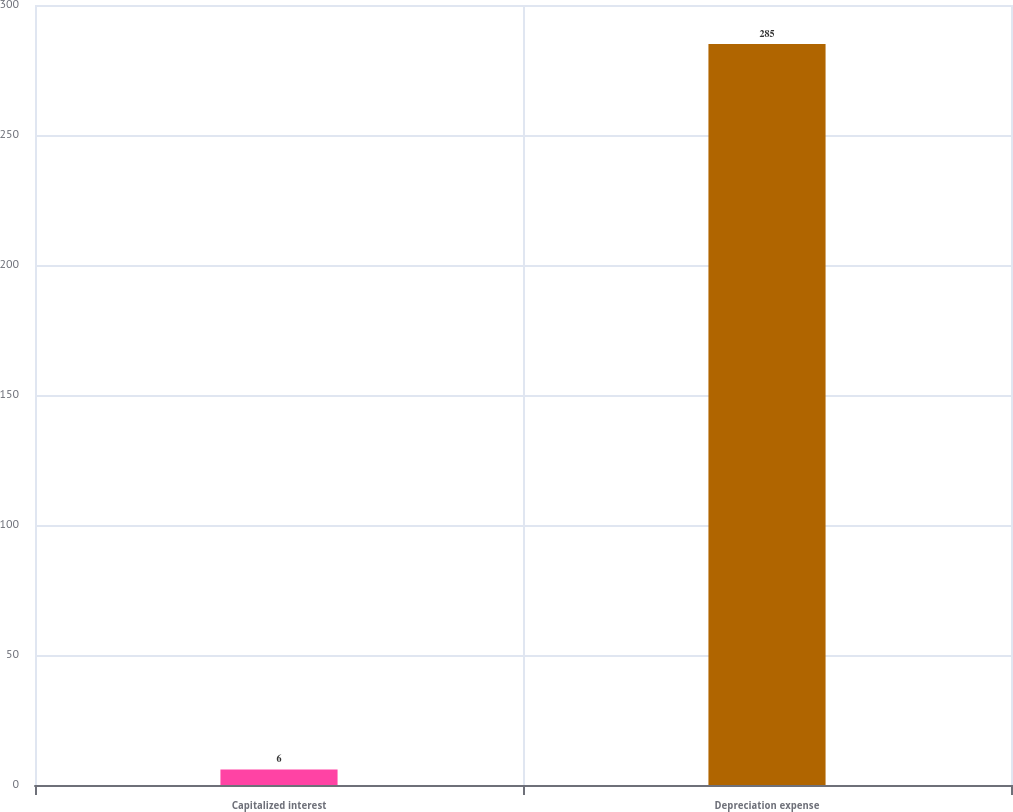Convert chart to OTSL. <chart><loc_0><loc_0><loc_500><loc_500><bar_chart><fcel>Capitalized interest<fcel>Depreciation expense<nl><fcel>6<fcel>285<nl></chart> 